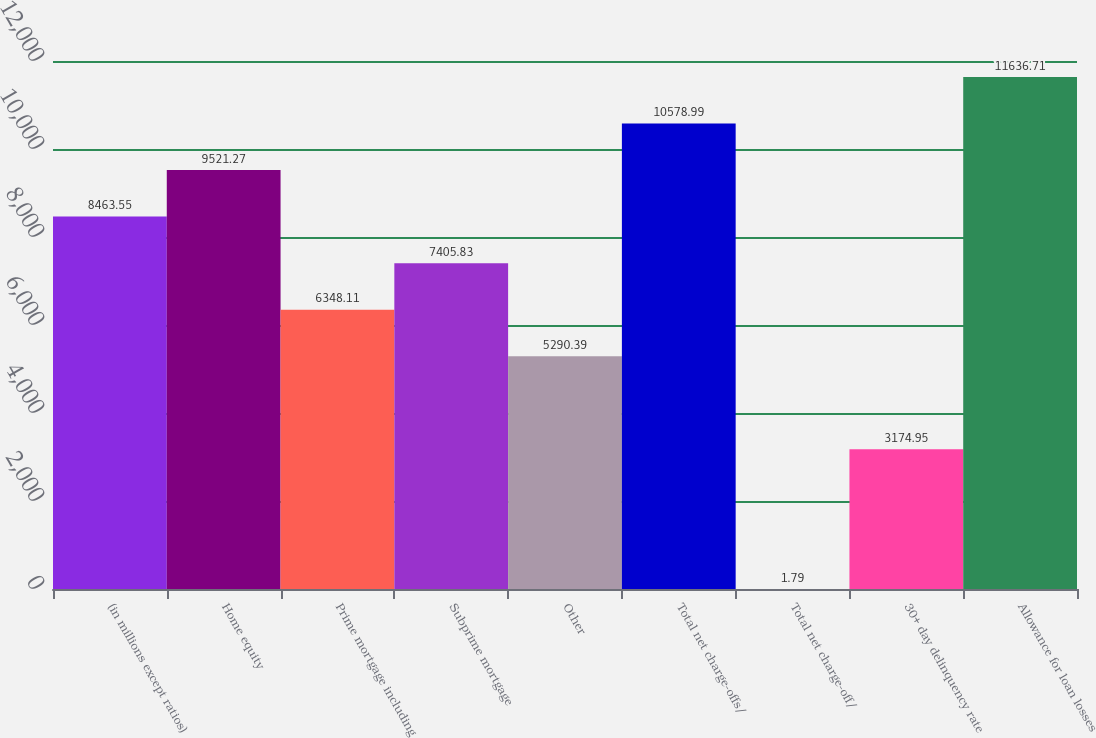Convert chart. <chart><loc_0><loc_0><loc_500><loc_500><bar_chart><fcel>(in millions except ratios)<fcel>Home equity<fcel>Prime mortgage including<fcel>Subprime mortgage<fcel>Other<fcel>Total net charge-offs/<fcel>Total net charge-off/<fcel>30+ day delinquency rate<fcel>Allowance for loan losses<nl><fcel>8463.55<fcel>9521.27<fcel>6348.11<fcel>7405.83<fcel>5290.39<fcel>10579<fcel>1.79<fcel>3174.95<fcel>11636.7<nl></chart> 